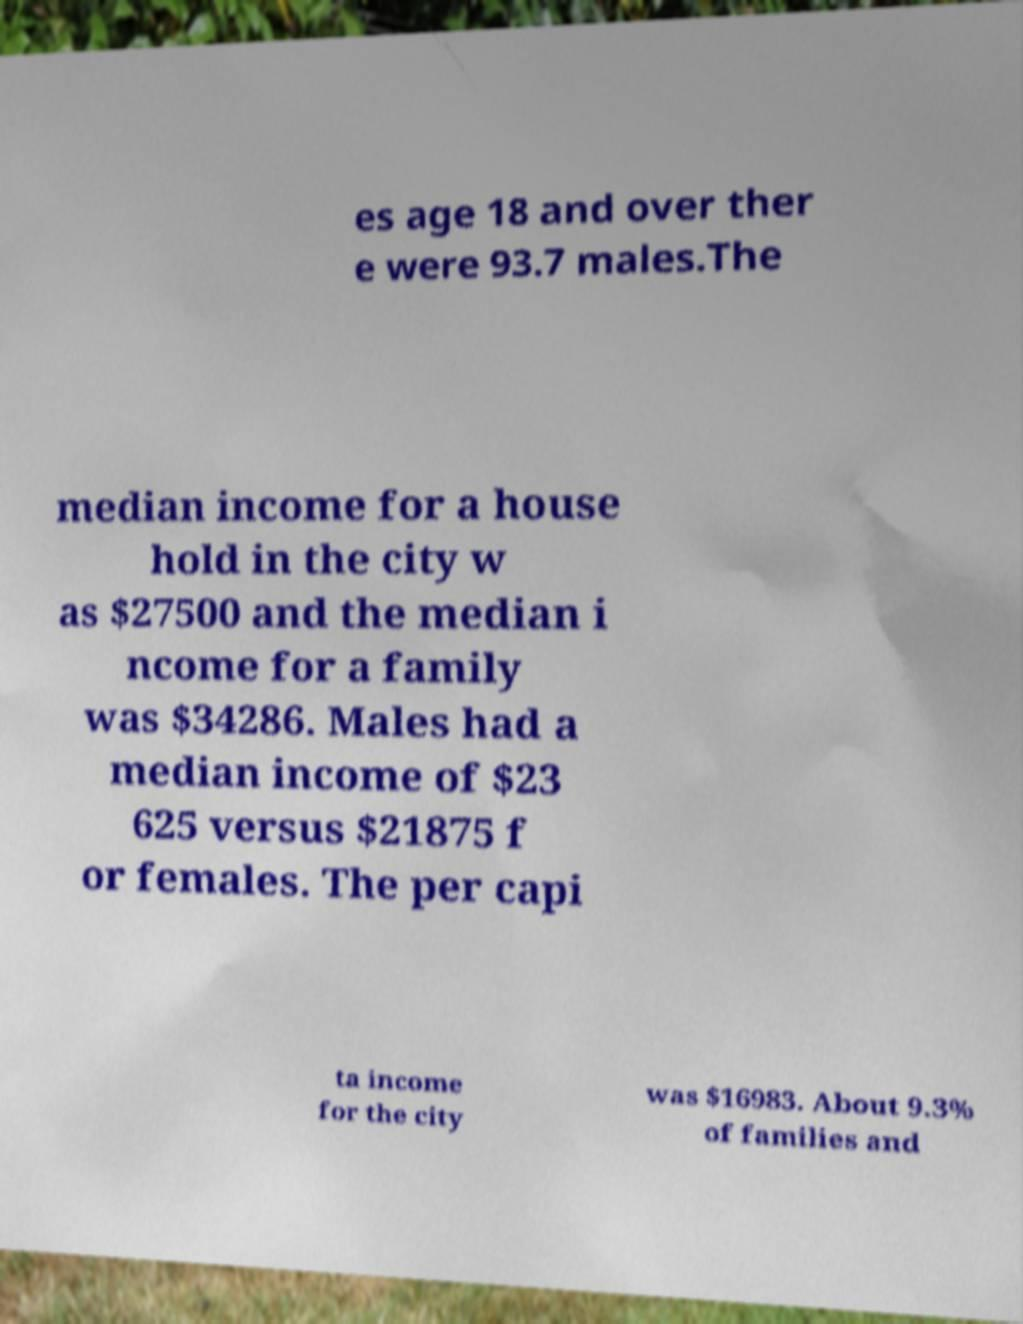Could you extract and type out the text from this image? es age 18 and over ther e were 93.7 males.The median income for a house hold in the city w as $27500 and the median i ncome for a family was $34286. Males had a median income of $23 625 versus $21875 f or females. The per capi ta income for the city was $16983. About 9.3% of families and 